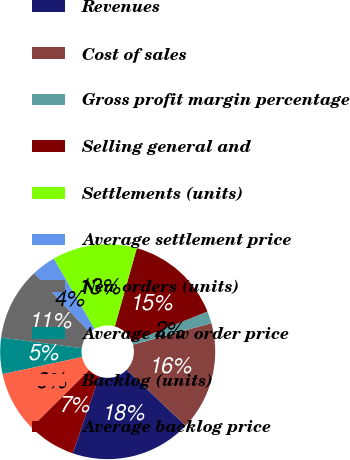<chart> <loc_0><loc_0><loc_500><loc_500><pie_chart><fcel>Revenues<fcel>Cost of sales<fcel>Gross profit margin percentage<fcel>Selling general and<fcel>Settlements (units)<fcel>Average settlement price<fcel>New orders (units)<fcel>Average new order price<fcel>Backlog (units)<fcel>Average backlog price<nl><fcel>18.18%<fcel>16.36%<fcel>1.82%<fcel>14.55%<fcel>12.73%<fcel>3.64%<fcel>10.91%<fcel>5.45%<fcel>9.09%<fcel>7.27%<nl></chart> 